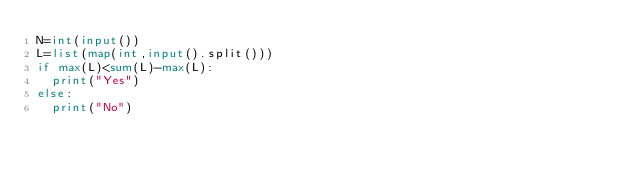<code> <loc_0><loc_0><loc_500><loc_500><_Python_>N=int(input())
L=list(map(int,input().split()))
if max(L)<sum(L)-max(L):
  print("Yes")
else:
  print("No")</code> 